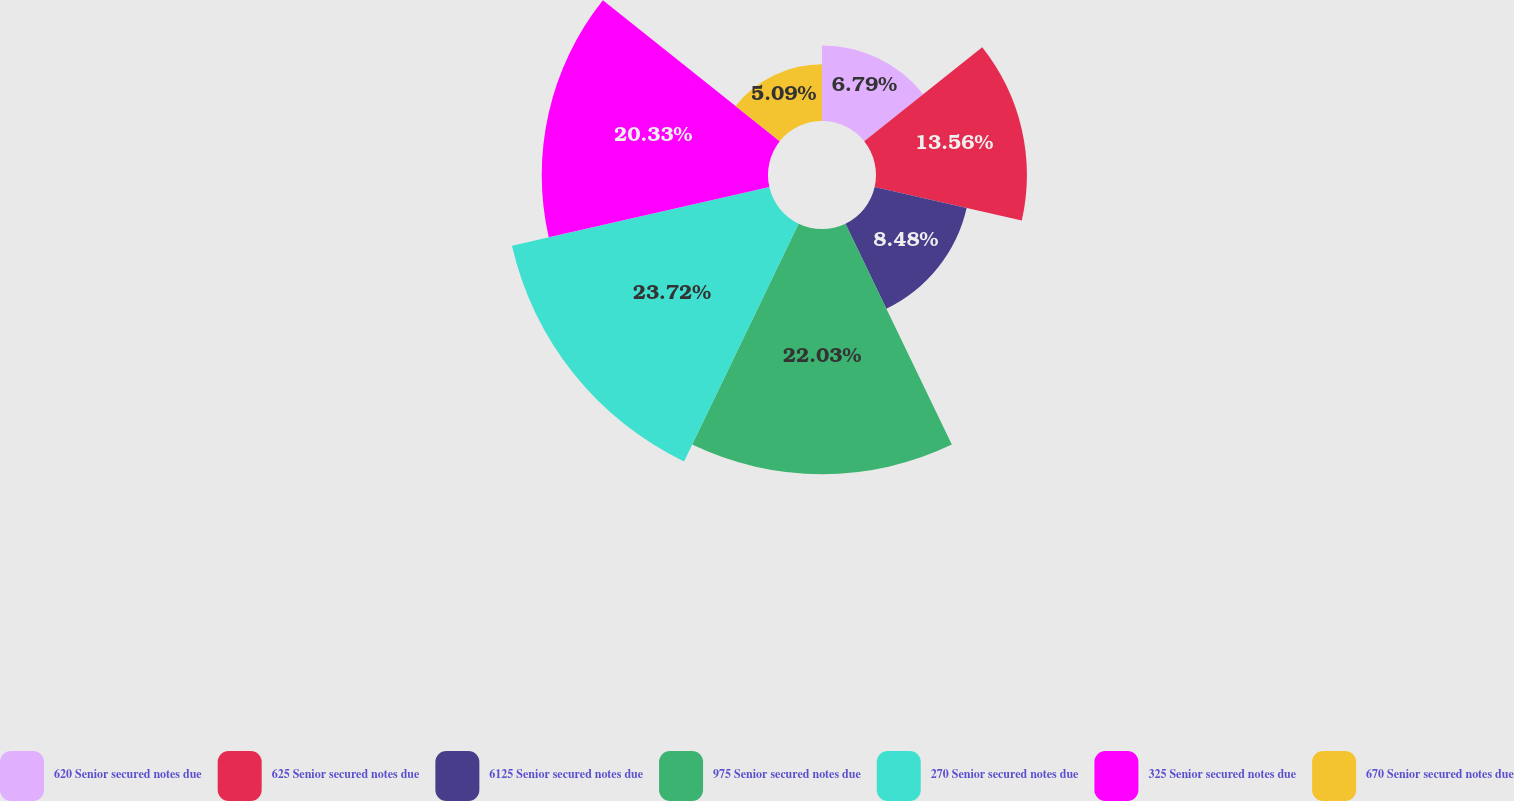Convert chart to OTSL. <chart><loc_0><loc_0><loc_500><loc_500><pie_chart><fcel>620 Senior secured notes due<fcel>625 Senior secured notes due<fcel>6125 Senior secured notes due<fcel>975 Senior secured notes due<fcel>270 Senior secured notes due<fcel>325 Senior secured notes due<fcel>670 Senior secured notes due<nl><fcel>6.79%<fcel>13.56%<fcel>8.48%<fcel>22.03%<fcel>23.72%<fcel>20.33%<fcel>5.09%<nl></chart> 